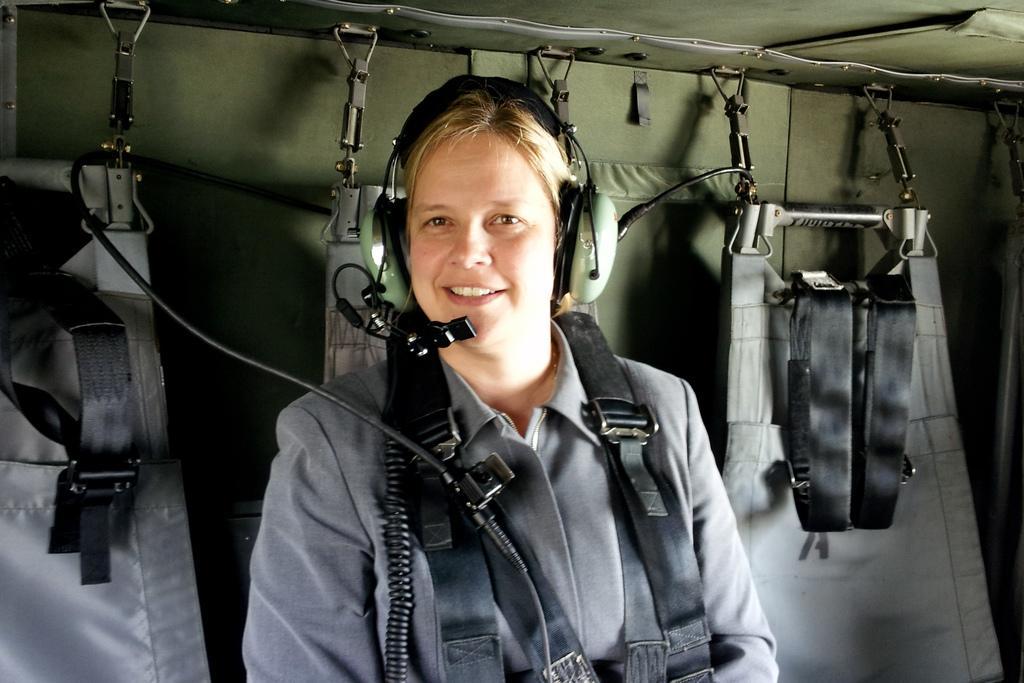Can you describe this image briefly? In this image in the center there is one woman and she is wearing a headset and smiling, and in the background there are some costumes and it looks like a cloth and some wires. 